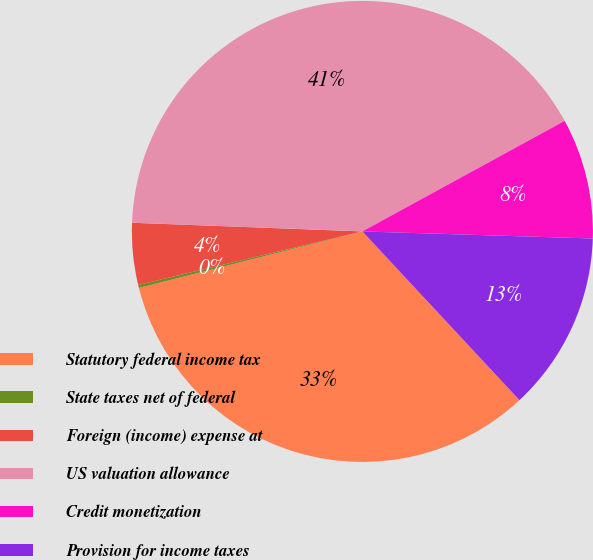Convert chart. <chart><loc_0><loc_0><loc_500><loc_500><pie_chart><fcel>Statutory federal income tax<fcel>State taxes net of federal<fcel>Foreign (income) expense at<fcel>US valuation allowance<fcel>Credit monetization<fcel>Provision for income taxes<nl><fcel>32.99%<fcel>0.21%<fcel>4.33%<fcel>41.44%<fcel>8.45%<fcel>12.58%<nl></chart> 